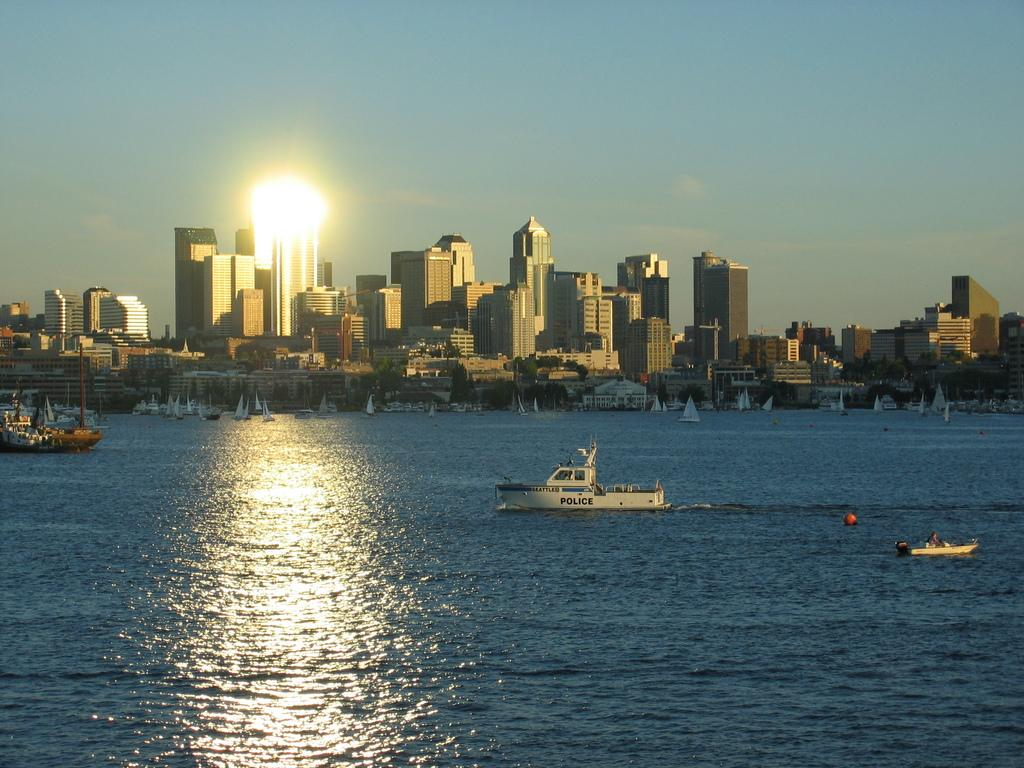What is in the water in the image? There are boats in the water in the image. What can be seen in the background of the image? There are many buildings visible in the background. What is a visual effect present in the image? There are light reflections in the image. What is visible in the sky in the image? Clouds are present in the sky. Who is the creator of the clouds in the image? The clouds in the image are a natural weather phenomenon and do not have a specific creator. Is there a church visible in the image? There is no mention of a church in the provided facts, so it cannot be determined if one is present in the image. 